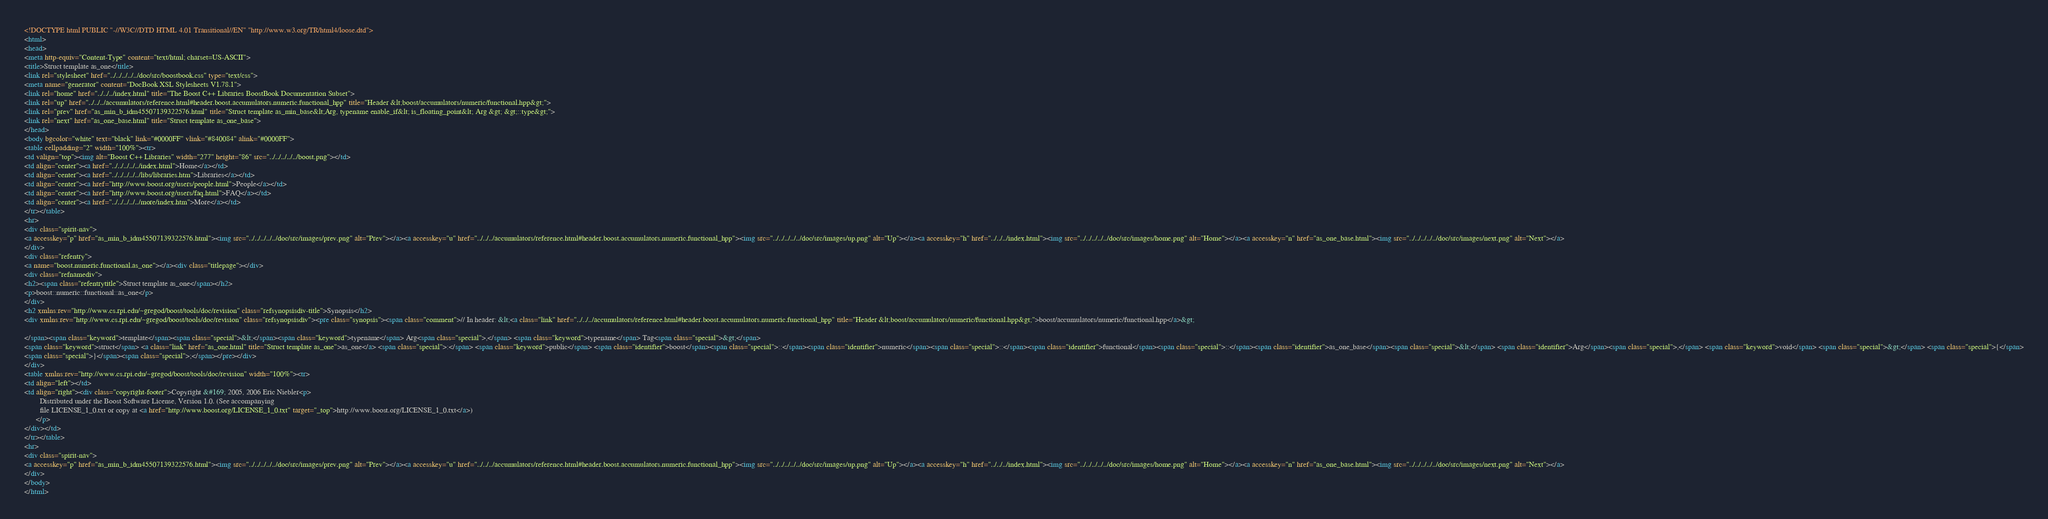Convert code to text. <code><loc_0><loc_0><loc_500><loc_500><_HTML_><!DOCTYPE html PUBLIC "-//W3C//DTD HTML 4.01 Transitional//EN" "http://www.w3.org/TR/html4/loose.dtd">
<html>
<head>
<meta http-equiv="Content-Type" content="text/html; charset=US-ASCII">
<title>Struct template as_one</title>
<link rel="stylesheet" href="../../../../../doc/src/boostbook.css" type="text/css">
<meta name="generator" content="DocBook XSL Stylesheets V1.78.1">
<link rel="home" href="../../../index.html" title="The Boost C++ Libraries BoostBook Documentation Subset">
<link rel="up" href="../../../accumulators/reference.html#header.boost.accumulators.numeric.functional_hpp" title="Header &lt;boost/accumulators/numeric/functional.hpp&gt;">
<link rel="prev" href="as_min_b_idm45507139322576.html" title="Struct template as_min_base&lt;Arg, typename enable_if&lt; is_floating_point&lt; Arg &gt; &gt;::type&gt;">
<link rel="next" href="as_one_base.html" title="Struct template as_one_base">
</head>
<body bgcolor="white" text="black" link="#0000FF" vlink="#840084" alink="#0000FF">
<table cellpadding="2" width="100%"><tr>
<td valign="top"><img alt="Boost C++ Libraries" width="277" height="86" src="../../../../../boost.png"></td>
<td align="center"><a href="../../../../../index.html">Home</a></td>
<td align="center"><a href="../../../../../libs/libraries.htm">Libraries</a></td>
<td align="center"><a href="http://www.boost.org/users/people.html">People</a></td>
<td align="center"><a href="http://www.boost.org/users/faq.html">FAQ</a></td>
<td align="center"><a href="../../../../../more/index.htm">More</a></td>
</tr></table>
<hr>
<div class="spirit-nav">
<a accesskey="p" href="as_min_b_idm45507139322576.html"><img src="../../../../../doc/src/images/prev.png" alt="Prev"></a><a accesskey="u" href="../../../accumulators/reference.html#header.boost.accumulators.numeric.functional_hpp"><img src="../../../../../doc/src/images/up.png" alt="Up"></a><a accesskey="h" href="../../../index.html"><img src="../../../../../doc/src/images/home.png" alt="Home"></a><a accesskey="n" href="as_one_base.html"><img src="../../../../../doc/src/images/next.png" alt="Next"></a>
</div>
<div class="refentry">
<a name="boost.numeric.functional.as_one"></a><div class="titlepage"></div>
<div class="refnamediv">
<h2><span class="refentrytitle">Struct template as_one</span></h2>
<p>boost::numeric::functional::as_one</p>
</div>
<h2 xmlns:rev="http://www.cs.rpi.edu/~gregod/boost/tools/doc/revision" class="refsynopsisdiv-title">Synopsis</h2>
<div xmlns:rev="http://www.cs.rpi.edu/~gregod/boost/tools/doc/revision" class="refsynopsisdiv"><pre class="synopsis"><span class="comment">// In header: &lt;<a class="link" href="../../../accumulators/reference.html#header.boost.accumulators.numeric.functional_hpp" title="Header &lt;boost/accumulators/numeric/functional.hpp&gt;">boost/accumulators/numeric/functional.hpp</a>&gt;

</span><span class="keyword">template</span><span class="special">&lt;</span><span class="keyword">typename</span> Arg<span class="special">,</span> <span class="keyword">typename</span> Tag<span class="special">&gt;</span> 
<span class="keyword">struct</span> <a class="link" href="as_one.html" title="Struct template as_one">as_one</a> <span class="special">:</span> <span class="keyword">public</span> <span class="identifier">boost</span><span class="special">::</span><span class="identifier">numeric</span><span class="special">::</span><span class="identifier">functional</span><span class="special">::</span><span class="identifier">as_one_base</span><span class="special">&lt;</span> <span class="identifier">Arg</span><span class="special">,</span> <span class="keyword">void</span> <span class="special">&gt;</span> <span class="special">{</span>
<span class="special">}</span><span class="special">;</span></pre></div>
</div>
<table xmlns:rev="http://www.cs.rpi.edu/~gregod/boost/tools/doc/revision" width="100%"><tr>
<td align="left"></td>
<td align="right"><div class="copyright-footer">Copyright &#169; 2005, 2006 Eric Niebler<p>
        Distributed under the Boost Software License, Version 1.0. (See accompanying
        file LICENSE_1_0.txt or copy at <a href="http://www.boost.org/LICENSE_1_0.txt" target="_top">http://www.boost.org/LICENSE_1_0.txt</a>)
      </p>
</div></td>
</tr></table>
<hr>
<div class="spirit-nav">
<a accesskey="p" href="as_min_b_idm45507139322576.html"><img src="../../../../../doc/src/images/prev.png" alt="Prev"></a><a accesskey="u" href="../../../accumulators/reference.html#header.boost.accumulators.numeric.functional_hpp"><img src="../../../../../doc/src/images/up.png" alt="Up"></a><a accesskey="h" href="../../../index.html"><img src="../../../../../doc/src/images/home.png" alt="Home"></a><a accesskey="n" href="as_one_base.html"><img src="../../../../../doc/src/images/next.png" alt="Next"></a>
</div>
</body>
</html>
</code> 